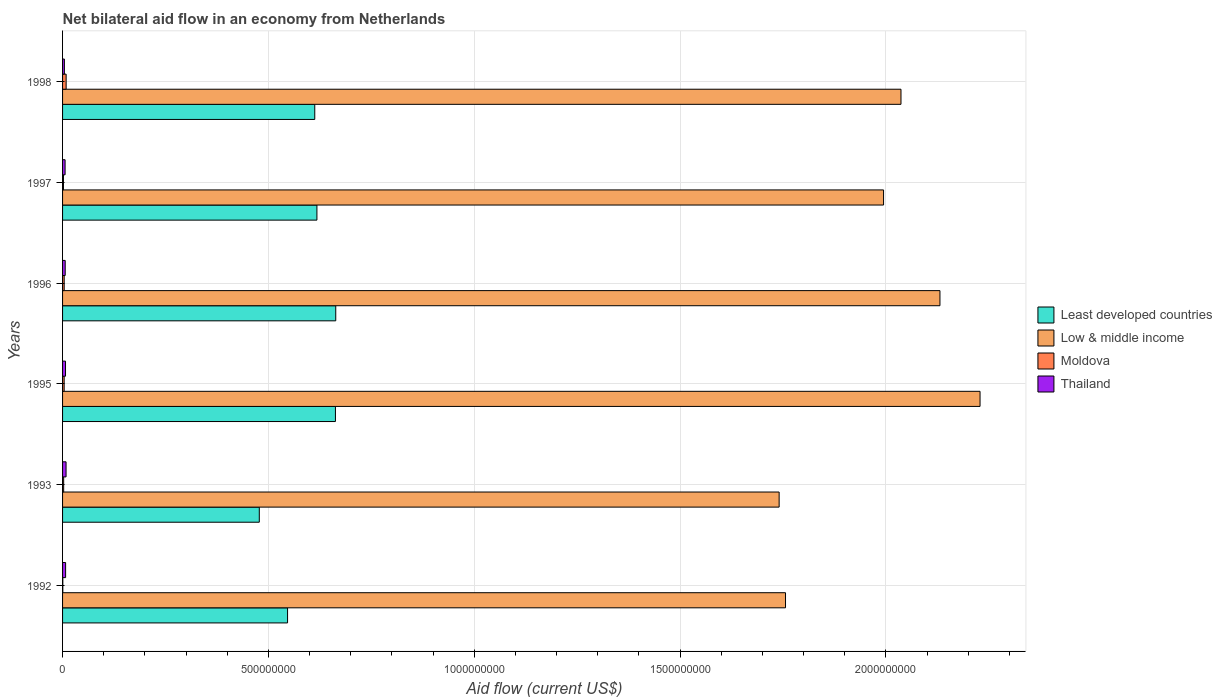Are the number of bars per tick equal to the number of legend labels?
Provide a short and direct response. Yes. What is the label of the 6th group of bars from the top?
Give a very brief answer. 1992. What is the net bilateral aid flow in Thailand in 1998?
Your response must be concise. 4.42e+06. Across all years, what is the maximum net bilateral aid flow in Moldova?
Your answer should be very brief. 8.70e+06. Across all years, what is the minimum net bilateral aid flow in Moldova?
Provide a succinct answer. 6.00e+05. In which year was the net bilateral aid flow in Least developed countries maximum?
Provide a succinct answer. 1996. In which year was the net bilateral aid flow in Least developed countries minimum?
Ensure brevity in your answer.  1993. What is the total net bilateral aid flow in Moldova in the graph?
Offer a terse response. 2.20e+07. What is the difference between the net bilateral aid flow in Low & middle income in 1993 and that in 1995?
Ensure brevity in your answer.  -4.88e+08. What is the difference between the net bilateral aid flow in Low & middle income in 1996 and the net bilateral aid flow in Least developed countries in 1995?
Keep it short and to the point. 1.47e+09. What is the average net bilateral aid flow in Moldova per year?
Provide a succinct answer. 3.67e+06. In the year 1997, what is the difference between the net bilateral aid flow in Least developed countries and net bilateral aid flow in Low & middle income?
Give a very brief answer. -1.38e+09. In how many years, is the net bilateral aid flow in Moldova greater than 600000000 US$?
Give a very brief answer. 0. What is the ratio of the net bilateral aid flow in Moldova in 1992 to that in 1996?
Give a very brief answer. 0.15. Is the net bilateral aid flow in Least developed countries in 1995 less than that in 1998?
Your response must be concise. No. What is the difference between the highest and the second highest net bilateral aid flow in Thailand?
Offer a very short reply. 1.12e+06. What is the difference between the highest and the lowest net bilateral aid flow in Least developed countries?
Make the answer very short. 1.86e+08. What does the 2nd bar from the top in 1996 represents?
Your answer should be very brief. Moldova. What does the 3rd bar from the bottom in 1997 represents?
Ensure brevity in your answer.  Moldova. How many bars are there?
Your answer should be very brief. 24. Are all the bars in the graph horizontal?
Keep it short and to the point. Yes. Are the values on the major ticks of X-axis written in scientific E-notation?
Provide a short and direct response. No. Does the graph contain any zero values?
Offer a very short reply. No. Does the graph contain grids?
Your response must be concise. Yes. Where does the legend appear in the graph?
Keep it short and to the point. Center right. How are the legend labels stacked?
Keep it short and to the point. Vertical. What is the title of the graph?
Give a very brief answer. Net bilateral aid flow in an economy from Netherlands. What is the label or title of the X-axis?
Make the answer very short. Aid flow (current US$). What is the Aid flow (current US$) of Least developed countries in 1992?
Ensure brevity in your answer.  5.47e+08. What is the Aid flow (current US$) of Low & middle income in 1992?
Ensure brevity in your answer.  1.76e+09. What is the Aid flow (current US$) of Thailand in 1992?
Provide a succinct answer. 7.39e+06. What is the Aid flow (current US$) of Least developed countries in 1993?
Your answer should be compact. 4.78e+08. What is the Aid flow (current US$) in Low & middle income in 1993?
Your answer should be very brief. 1.74e+09. What is the Aid flow (current US$) in Moldova in 1993?
Offer a terse response. 2.69e+06. What is the Aid flow (current US$) of Thailand in 1993?
Keep it short and to the point. 8.51e+06. What is the Aid flow (current US$) of Least developed countries in 1995?
Your answer should be compact. 6.63e+08. What is the Aid flow (current US$) in Low & middle income in 1995?
Your response must be concise. 2.23e+09. What is the Aid flow (current US$) of Moldova in 1995?
Offer a very short reply. 3.87e+06. What is the Aid flow (current US$) of Thailand in 1995?
Provide a succinct answer. 7.16e+06. What is the Aid flow (current US$) of Least developed countries in 1996?
Provide a short and direct response. 6.64e+08. What is the Aid flow (current US$) in Low & middle income in 1996?
Your response must be concise. 2.13e+09. What is the Aid flow (current US$) of Moldova in 1996?
Offer a terse response. 3.95e+06. What is the Aid flow (current US$) in Thailand in 1996?
Your answer should be very brief. 6.42e+06. What is the Aid flow (current US$) of Least developed countries in 1997?
Provide a short and direct response. 6.18e+08. What is the Aid flow (current US$) in Low & middle income in 1997?
Your answer should be very brief. 1.99e+09. What is the Aid flow (current US$) in Moldova in 1997?
Offer a terse response. 2.19e+06. What is the Aid flow (current US$) of Thailand in 1997?
Provide a short and direct response. 6.13e+06. What is the Aid flow (current US$) in Least developed countries in 1998?
Ensure brevity in your answer.  6.13e+08. What is the Aid flow (current US$) in Low & middle income in 1998?
Make the answer very short. 2.04e+09. What is the Aid flow (current US$) in Moldova in 1998?
Ensure brevity in your answer.  8.70e+06. What is the Aid flow (current US$) of Thailand in 1998?
Give a very brief answer. 4.42e+06. Across all years, what is the maximum Aid flow (current US$) of Least developed countries?
Keep it short and to the point. 6.64e+08. Across all years, what is the maximum Aid flow (current US$) in Low & middle income?
Give a very brief answer. 2.23e+09. Across all years, what is the maximum Aid flow (current US$) in Moldova?
Your answer should be very brief. 8.70e+06. Across all years, what is the maximum Aid flow (current US$) in Thailand?
Your answer should be compact. 8.51e+06. Across all years, what is the minimum Aid flow (current US$) in Least developed countries?
Provide a short and direct response. 4.78e+08. Across all years, what is the minimum Aid flow (current US$) of Low & middle income?
Provide a succinct answer. 1.74e+09. Across all years, what is the minimum Aid flow (current US$) in Moldova?
Provide a short and direct response. 6.00e+05. Across all years, what is the minimum Aid flow (current US$) of Thailand?
Give a very brief answer. 4.42e+06. What is the total Aid flow (current US$) of Least developed countries in the graph?
Keep it short and to the point. 3.58e+09. What is the total Aid flow (current US$) in Low & middle income in the graph?
Offer a terse response. 1.19e+1. What is the total Aid flow (current US$) in Moldova in the graph?
Keep it short and to the point. 2.20e+07. What is the total Aid flow (current US$) in Thailand in the graph?
Ensure brevity in your answer.  4.00e+07. What is the difference between the Aid flow (current US$) of Least developed countries in 1992 and that in 1993?
Make the answer very short. 6.87e+07. What is the difference between the Aid flow (current US$) of Low & middle income in 1992 and that in 1993?
Give a very brief answer. 1.55e+07. What is the difference between the Aid flow (current US$) in Moldova in 1992 and that in 1993?
Make the answer very short. -2.09e+06. What is the difference between the Aid flow (current US$) of Thailand in 1992 and that in 1993?
Offer a terse response. -1.12e+06. What is the difference between the Aid flow (current US$) in Least developed countries in 1992 and that in 1995?
Provide a short and direct response. -1.16e+08. What is the difference between the Aid flow (current US$) in Low & middle income in 1992 and that in 1995?
Give a very brief answer. -4.73e+08. What is the difference between the Aid flow (current US$) of Moldova in 1992 and that in 1995?
Offer a very short reply. -3.27e+06. What is the difference between the Aid flow (current US$) in Thailand in 1992 and that in 1995?
Ensure brevity in your answer.  2.30e+05. What is the difference between the Aid flow (current US$) of Least developed countries in 1992 and that in 1996?
Give a very brief answer. -1.17e+08. What is the difference between the Aid flow (current US$) of Low & middle income in 1992 and that in 1996?
Offer a terse response. -3.75e+08. What is the difference between the Aid flow (current US$) in Moldova in 1992 and that in 1996?
Give a very brief answer. -3.35e+06. What is the difference between the Aid flow (current US$) in Thailand in 1992 and that in 1996?
Offer a very short reply. 9.70e+05. What is the difference between the Aid flow (current US$) of Least developed countries in 1992 and that in 1997?
Provide a succinct answer. -7.13e+07. What is the difference between the Aid flow (current US$) in Low & middle income in 1992 and that in 1997?
Your answer should be very brief. -2.38e+08. What is the difference between the Aid flow (current US$) of Moldova in 1992 and that in 1997?
Provide a short and direct response. -1.59e+06. What is the difference between the Aid flow (current US$) in Thailand in 1992 and that in 1997?
Offer a terse response. 1.26e+06. What is the difference between the Aid flow (current US$) of Least developed countries in 1992 and that in 1998?
Provide a succinct answer. -6.61e+07. What is the difference between the Aid flow (current US$) of Low & middle income in 1992 and that in 1998?
Your answer should be very brief. -2.80e+08. What is the difference between the Aid flow (current US$) of Moldova in 1992 and that in 1998?
Your answer should be very brief. -8.10e+06. What is the difference between the Aid flow (current US$) of Thailand in 1992 and that in 1998?
Your answer should be compact. 2.97e+06. What is the difference between the Aid flow (current US$) in Least developed countries in 1993 and that in 1995?
Give a very brief answer. -1.85e+08. What is the difference between the Aid flow (current US$) in Low & middle income in 1993 and that in 1995?
Offer a terse response. -4.88e+08. What is the difference between the Aid flow (current US$) of Moldova in 1993 and that in 1995?
Your answer should be very brief. -1.18e+06. What is the difference between the Aid flow (current US$) in Thailand in 1993 and that in 1995?
Ensure brevity in your answer.  1.35e+06. What is the difference between the Aid flow (current US$) of Least developed countries in 1993 and that in 1996?
Your answer should be very brief. -1.86e+08. What is the difference between the Aid flow (current US$) of Low & middle income in 1993 and that in 1996?
Your answer should be compact. -3.91e+08. What is the difference between the Aid flow (current US$) of Moldova in 1993 and that in 1996?
Your response must be concise. -1.26e+06. What is the difference between the Aid flow (current US$) of Thailand in 1993 and that in 1996?
Make the answer very short. 2.09e+06. What is the difference between the Aid flow (current US$) of Least developed countries in 1993 and that in 1997?
Offer a very short reply. -1.40e+08. What is the difference between the Aid flow (current US$) of Low & middle income in 1993 and that in 1997?
Offer a terse response. -2.54e+08. What is the difference between the Aid flow (current US$) in Moldova in 1993 and that in 1997?
Your answer should be compact. 5.00e+05. What is the difference between the Aid flow (current US$) in Thailand in 1993 and that in 1997?
Your answer should be compact. 2.38e+06. What is the difference between the Aid flow (current US$) in Least developed countries in 1993 and that in 1998?
Offer a terse response. -1.35e+08. What is the difference between the Aid flow (current US$) of Low & middle income in 1993 and that in 1998?
Keep it short and to the point. -2.96e+08. What is the difference between the Aid flow (current US$) in Moldova in 1993 and that in 1998?
Offer a very short reply. -6.01e+06. What is the difference between the Aid flow (current US$) of Thailand in 1993 and that in 1998?
Offer a very short reply. 4.09e+06. What is the difference between the Aid flow (current US$) of Least developed countries in 1995 and that in 1996?
Your answer should be very brief. -7.40e+05. What is the difference between the Aid flow (current US$) in Low & middle income in 1995 and that in 1996?
Keep it short and to the point. 9.74e+07. What is the difference between the Aid flow (current US$) of Thailand in 1995 and that in 1996?
Ensure brevity in your answer.  7.40e+05. What is the difference between the Aid flow (current US$) in Least developed countries in 1995 and that in 1997?
Provide a succinct answer. 4.50e+07. What is the difference between the Aid flow (current US$) of Low & middle income in 1995 and that in 1997?
Ensure brevity in your answer.  2.34e+08. What is the difference between the Aid flow (current US$) of Moldova in 1995 and that in 1997?
Your response must be concise. 1.68e+06. What is the difference between the Aid flow (current US$) of Thailand in 1995 and that in 1997?
Your answer should be very brief. 1.03e+06. What is the difference between the Aid flow (current US$) in Least developed countries in 1995 and that in 1998?
Provide a succinct answer. 5.02e+07. What is the difference between the Aid flow (current US$) in Low & middle income in 1995 and that in 1998?
Ensure brevity in your answer.  1.92e+08. What is the difference between the Aid flow (current US$) of Moldova in 1995 and that in 1998?
Your answer should be compact. -4.83e+06. What is the difference between the Aid flow (current US$) of Thailand in 1995 and that in 1998?
Provide a succinct answer. 2.74e+06. What is the difference between the Aid flow (current US$) in Least developed countries in 1996 and that in 1997?
Make the answer very short. 4.57e+07. What is the difference between the Aid flow (current US$) in Low & middle income in 1996 and that in 1997?
Ensure brevity in your answer.  1.37e+08. What is the difference between the Aid flow (current US$) in Moldova in 1996 and that in 1997?
Offer a terse response. 1.76e+06. What is the difference between the Aid flow (current US$) of Thailand in 1996 and that in 1997?
Offer a very short reply. 2.90e+05. What is the difference between the Aid flow (current US$) in Least developed countries in 1996 and that in 1998?
Give a very brief answer. 5.10e+07. What is the difference between the Aid flow (current US$) of Low & middle income in 1996 and that in 1998?
Offer a very short reply. 9.47e+07. What is the difference between the Aid flow (current US$) in Moldova in 1996 and that in 1998?
Your response must be concise. -4.75e+06. What is the difference between the Aid flow (current US$) in Thailand in 1996 and that in 1998?
Make the answer very short. 2.00e+06. What is the difference between the Aid flow (current US$) of Least developed countries in 1997 and that in 1998?
Offer a very short reply. 5.23e+06. What is the difference between the Aid flow (current US$) of Low & middle income in 1997 and that in 1998?
Provide a succinct answer. -4.23e+07. What is the difference between the Aid flow (current US$) of Moldova in 1997 and that in 1998?
Keep it short and to the point. -6.51e+06. What is the difference between the Aid flow (current US$) in Thailand in 1997 and that in 1998?
Keep it short and to the point. 1.71e+06. What is the difference between the Aid flow (current US$) of Least developed countries in 1992 and the Aid flow (current US$) of Low & middle income in 1993?
Offer a terse response. -1.19e+09. What is the difference between the Aid flow (current US$) of Least developed countries in 1992 and the Aid flow (current US$) of Moldova in 1993?
Offer a very short reply. 5.44e+08. What is the difference between the Aid flow (current US$) in Least developed countries in 1992 and the Aid flow (current US$) in Thailand in 1993?
Ensure brevity in your answer.  5.38e+08. What is the difference between the Aid flow (current US$) of Low & middle income in 1992 and the Aid flow (current US$) of Moldova in 1993?
Give a very brief answer. 1.75e+09. What is the difference between the Aid flow (current US$) in Low & middle income in 1992 and the Aid flow (current US$) in Thailand in 1993?
Provide a succinct answer. 1.75e+09. What is the difference between the Aid flow (current US$) in Moldova in 1992 and the Aid flow (current US$) in Thailand in 1993?
Your response must be concise. -7.91e+06. What is the difference between the Aid flow (current US$) of Least developed countries in 1992 and the Aid flow (current US$) of Low & middle income in 1995?
Your answer should be compact. -1.68e+09. What is the difference between the Aid flow (current US$) in Least developed countries in 1992 and the Aid flow (current US$) in Moldova in 1995?
Your answer should be very brief. 5.43e+08. What is the difference between the Aid flow (current US$) of Least developed countries in 1992 and the Aid flow (current US$) of Thailand in 1995?
Give a very brief answer. 5.39e+08. What is the difference between the Aid flow (current US$) in Low & middle income in 1992 and the Aid flow (current US$) in Moldova in 1995?
Provide a succinct answer. 1.75e+09. What is the difference between the Aid flow (current US$) in Low & middle income in 1992 and the Aid flow (current US$) in Thailand in 1995?
Ensure brevity in your answer.  1.75e+09. What is the difference between the Aid flow (current US$) in Moldova in 1992 and the Aid flow (current US$) in Thailand in 1995?
Give a very brief answer. -6.56e+06. What is the difference between the Aid flow (current US$) in Least developed countries in 1992 and the Aid flow (current US$) in Low & middle income in 1996?
Your answer should be very brief. -1.58e+09. What is the difference between the Aid flow (current US$) of Least developed countries in 1992 and the Aid flow (current US$) of Moldova in 1996?
Your answer should be compact. 5.43e+08. What is the difference between the Aid flow (current US$) in Least developed countries in 1992 and the Aid flow (current US$) in Thailand in 1996?
Keep it short and to the point. 5.40e+08. What is the difference between the Aid flow (current US$) of Low & middle income in 1992 and the Aid flow (current US$) of Moldova in 1996?
Ensure brevity in your answer.  1.75e+09. What is the difference between the Aid flow (current US$) of Low & middle income in 1992 and the Aid flow (current US$) of Thailand in 1996?
Keep it short and to the point. 1.75e+09. What is the difference between the Aid flow (current US$) in Moldova in 1992 and the Aid flow (current US$) in Thailand in 1996?
Make the answer very short. -5.82e+06. What is the difference between the Aid flow (current US$) of Least developed countries in 1992 and the Aid flow (current US$) of Low & middle income in 1997?
Offer a very short reply. -1.45e+09. What is the difference between the Aid flow (current US$) in Least developed countries in 1992 and the Aid flow (current US$) in Moldova in 1997?
Your answer should be compact. 5.44e+08. What is the difference between the Aid flow (current US$) of Least developed countries in 1992 and the Aid flow (current US$) of Thailand in 1997?
Your answer should be very brief. 5.40e+08. What is the difference between the Aid flow (current US$) in Low & middle income in 1992 and the Aid flow (current US$) in Moldova in 1997?
Offer a terse response. 1.75e+09. What is the difference between the Aid flow (current US$) in Low & middle income in 1992 and the Aid flow (current US$) in Thailand in 1997?
Offer a very short reply. 1.75e+09. What is the difference between the Aid flow (current US$) in Moldova in 1992 and the Aid flow (current US$) in Thailand in 1997?
Ensure brevity in your answer.  -5.53e+06. What is the difference between the Aid flow (current US$) of Least developed countries in 1992 and the Aid flow (current US$) of Low & middle income in 1998?
Provide a short and direct response. -1.49e+09. What is the difference between the Aid flow (current US$) of Least developed countries in 1992 and the Aid flow (current US$) of Moldova in 1998?
Ensure brevity in your answer.  5.38e+08. What is the difference between the Aid flow (current US$) in Least developed countries in 1992 and the Aid flow (current US$) in Thailand in 1998?
Give a very brief answer. 5.42e+08. What is the difference between the Aid flow (current US$) in Low & middle income in 1992 and the Aid flow (current US$) in Moldova in 1998?
Offer a very short reply. 1.75e+09. What is the difference between the Aid flow (current US$) of Low & middle income in 1992 and the Aid flow (current US$) of Thailand in 1998?
Ensure brevity in your answer.  1.75e+09. What is the difference between the Aid flow (current US$) in Moldova in 1992 and the Aid flow (current US$) in Thailand in 1998?
Make the answer very short. -3.82e+06. What is the difference between the Aid flow (current US$) in Least developed countries in 1993 and the Aid flow (current US$) in Low & middle income in 1995?
Offer a very short reply. -1.75e+09. What is the difference between the Aid flow (current US$) of Least developed countries in 1993 and the Aid flow (current US$) of Moldova in 1995?
Your answer should be compact. 4.74e+08. What is the difference between the Aid flow (current US$) of Least developed countries in 1993 and the Aid flow (current US$) of Thailand in 1995?
Make the answer very short. 4.71e+08. What is the difference between the Aid flow (current US$) in Low & middle income in 1993 and the Aid flow (current US$) in Moldova in 1995?
Give a very brief answer. 1.74e+09. What is the difference between the Aid flow (current US$) in Low & middle income in 1993 and the Aid flow (current US$) in Thailand in 1995?
Provide a short and direct response. 1.73e+09. What is the difference between the Aid flow (current US$) of Moldova in 1993 and the Aid flow (current US$) of Thailand in 1995?
Offer a terse response. -4.47e+06. What is the difference between the Aid flow (current US$) in Least developed countries in 1993 and the Aid flow (current US$) in Low & middle income in 1996?
Make the answer very short. -1.65e+09. What is the difference between the Aid flow (current US$) of Least developed countries in 1993 and the Aid flow (current US$) of Moldova in 1996?
Offer a terse response. 4.74e+08. What is the difference between the Aid flow (current US$) in Least developed countries in 1993 and the Aid flow (current US$) in Thailand in 1996?
Make the answer very short. 4.71e+08. What is the difference between the Aid flow (current US$) of Low & middle income in 1993 and the Aid flow (current US$) of Moldova in 1996?
Keep it short and to the point. 1.74e+09. What is the difference between the Aid flow (current US$) in Low & middle income in 1993 and the Aid flow (current US$) in Thailand in 1996?
Give a very brief answer. 1.73e+09. What is the difference between the Aid flow (current US$) in Moldova in 1993 and the Aid flow (current US$) in Thailand in 1996?
Offer a terse response. -3.73e+06. What is the difference between the Aid flow (current US$) of Least developed countries in 1993 and the Aid flow (current US$) of Low & middle income in 1997?
Give a very brief answer. -1.52e+09. What is the difference between the Aid flow (current US$) in Least developed countries in 1993 and the Aid flow (current US$) in Moldova in 1997?
Your response must be concise. 4.76e+08. What is the difference between the Aid flow (current US$) of Least developed countries in 1993 and the Aid flow (current US$) of Thailand in 1997?
Your answer should be very brief. 4.72e+08. What is the difference between the Aid flow (current US$) in Low & middle income in 1993 and the Aid flow (current US$) in Moldova in 1997?
Offer a very short reply. 1.74e+09. What is the difference between the Aid flow (current US$) in Low & middle income in 1993 and the Aid flow (current US$) in Thailand in 1997?
Keep it short and to the point. 1.73e+09. What is the difference between the Aid flow (current US$) in Moldova in 1993 and the Aid flow (current US$) in Thailand in 1997?
Your answer should be compact. -3.44e+06. What is the difference between the Aid flow (current US$) in Least developed countries in 1993 and the Aid flow (current US$) in Low & middle income in 1998?
Offer a very short reply. -1.56e+09. What is the difference between the Aid flow (current US$) of Least developed countries in 1993 and the Aid flow (current US$) of Moldova in 1998?
Give a very brief answer. 4.69e+08. What is the difference between the Aid flow (current US$) of Least developed countries in 1993 and the Aid flow (current US$) of Thailand in 1998?
Keep it short and to the point. 4.73e+08. What is the difference between the Aid flow (current US$) of Low & middle income in 1993 and the Aid flow (current US$) of Moldova in 1998?
Your answer should be very brief. 1.73e+09. What is the difference between the Aid flow (current US$) in Low & middle income in 1993 and the Aid flow (current US$) in Thailand in 1998?
Your answer should be very brief. 1.74e+09. What is the difference between the Aid flow (current US$) of Moldova in 1993 and the Aid flow (current US$) of Thailand in 1998?
Offer a very short reply. -1.73e+06. What is the difference between the Aid flow (current US$) of Least developed countries in 1995 and the Aid flow (current US$) of Low & middle income in 1996?
Make the answer very short. -1.47e+09. What is the difference between the Aid flow (current US$) in Least developed countries in 1995 and the Aid flow (current US$) in Moldova in 1996?
Your response must be concise. 6.59e+08. What is the difference between the Aid flow (current US$) of Least developed countries in 1995 and the Aid flow (current US$) of Thailand in 1996?
Your answer should be very brief. 6.56e+08. What is the difference between the Aid flow (current US$) of Low & middle income in 1995 and the Aid flow (current US$) of Moldova in 1996?
Ensure brevity in your answer.  2.22e+09. What is the difference between the Aid flow (current US$) of Low & middle income in 1995 and the Aid flow (current US$) of Thailand in 1996?
Your answer should be very brief. 2.22e+09. What is the difference between the Aid flow (current US$) in Moldova in 1995 and the Aid flow (current US$) in Thailand in 1996?
Make the answer very short. -2.55e+06. What is the difference between the Aid flow (current US$) in Least developed countries in 1995 and the Aid flow (current US$) in Low & middle income in 1997?
Provide a succinct answer. -1.33e+09. What is the difference between the Aid flow (current US$) of Least developed countries in 1995 and the Aid flow (current US$) of Moldova in 1997?
Your response must be concise. 6.61e+08. What is the difference between the Aid flow (current US$) of Least developed countries in 1995 and the Aid flow (current US$) of Thailand in 1997?
Your response must be concise. 6.57e+08. What is the difference between the Aid flow (current US$) of Low & middle income in 1995 and the Aid flow (current US$) of Moldova in 1997?
Your response must be concise. 2.23e+09. What is the difference between the Aid flow (current US$) in Low & middle income in 1995 and the Aid flow (current US$) in Thailand in 1997?
Make the answer very short. 2.22e+09. What is the difference between the Aid flow (current US$) in Moldova in 1995 and the Aid flow (current US$) in Thailand in 1997?
Make the answer very short. -2.26e+06. What is the difference between the Aid flow (current US$) of Least developed countries in 1995 and the Aid flow (current US$) of Low & middle income in 1998?
Ensure brevity in your answer.  -1.37e+09. What is the difference between the Aid flow (current US$) in Least developed countries in 1995 and the Aid flow (current US$) in Moldova in 1998?
Your answer should be compact. 6.54e+08. What is the difference between the Aid flow (current US$) of Least developed countries in 1995 and the Aid flow (current US$) of Thailand in 1998?
Provide a short and direct response. 6.58e+08. What is the difference between the Aid flow (current US$) of Low & middle income in 1995 and the Aid flow (current US$) of Moldova in 1998?
Your answer should be very brief. 2.22e+09. What is the difference between the Aid flow (current US$) of Low & middle income in 1995 and the Aid flow (current US$) of Thailand in 1998?
Your answer should be very brief. 2.22e+09. What is the difference between the Aid flow (current US$) in Moldova in 1995 and the Aid flow (current US$) in Thailand in 1998?
Your answer should be very brief. -5.50e+05. What is the difference between the Aid flow (current US$) of Least developed countries in 1996 and the Aid flow (current US$) of Low & middle income in 1997?
Your answer should be very brief. -1.33e+09. What is the difference between the Aid flow (current US$) in Least developed countries in 1996 and the Aid flow (current US$) in Moldova in 1997?
Keep it short and to the point. 6.61e+08. What is the difference between the Aid flow (current US$) in Least developed countries in 1996 and the Aid flow (current US$) in Thailand in 1997?
Ensure brevity in your answer.  6.57e+08. What is the difference between the Aid flow (current US$) in Low & middle income in 1996 and the Aid flow (current US$) in Moldova in 1997?
Your response must be concise. 2.13e+09. What is the difference between the Aid flow (current US$) in Low & middle income in 1996 and the Aid flow (current US$) in Thailand in 1997?
Your response must be concise. 2.13e+09. What is the difference between the Aid flow (current US$) in Moldova in 1996 and the Aid flow (current US$) in Thailand in 1997?
Ensure brevity in your answer.  -2.18e+06. What is the difference between the Aid flow (current US$) in Least developed countries in 1996 and the Aid flow (current US$) in Low & middle income in 1998?
Ensure brevity in your answer.  -1.37e+09. What is the difference between the Aid flow (current US$) of Least developed countries in 1996 and the Aid flow (current US$) of Moldova in 1998?
Give a very brief answer. 6.55e+08. What is the difference between the Aid flow (current US$) of Least developed countries in 1996 and the Aid flow (current US$) of Thailand in 1998?
Offer a terse response. 6.59e+08. What is the difference between the Aid flow (current US$) of Low & middle income in 1996 and the Aid flow (current US$) of Moldova in 1998?
Provide a short and direct response. 2.12e+09. What is the difference between the Aid flow (current US$) of Low & middle income in 1996 and the Aid flow (current US$) of Thailand in 1998?
Your answer should be very brief. 2.13e+09. What is the difference between the Aid flow (current US$) in Moldova in 1996 and the Aid flow (current US$) in Thailand in 1998?
Your response must be concise. -4.70e+05. What is the difference between the Aid flow (current US$) in Least developed countries in 1997 and the Aid flow (current US$) in Low & middle income in 1998?
Ensure brevity in your answer.  -1.42e+09. What is the difference between the Aid flow (current US$) in Least developed countries in 1997 and the Aid flow (current US$) in Moldova in 1998?
Give a very brief answer. 6.09e+08. What is the difference between the Aid flow (current US$) of Least developed countries in 1997 and the Aid flow (current US$) of Thailand in 1998?
Your response must be concise. 6.13e+08. What is the difference between the Aid flow (current US$) in Low & middle income in 1997 and the Aid flow (current US$) in Moldova in 1998?
Give a very brief answer. 1.99e+09. What is the difference between the Aid flow (current US$) of Low & middle income in 1997 and the Aid flow (current US$) of Thailand in 1998?
Give a very brief answer. 1.99e+09. What is the difference between the Aid flow (current US$) of Moldova in 1997 and the Aid flow (current US$) of Thailand in 1998?
Offer a terse response. -2.23e+06. What is the average Aid flow (current US$) in Least developed countries per year?
Your answer should be very brief. 5.97e+08. What is the average Aid flow (current US$) in Low & middle income per year?
Give a very brief answer. 1.98e+09. What is the average Aid flow (current US$) of Moldova per year?
Keep it short and to the point. 3.67e+06. What is the average Aid flow (current US$) in Thailand per year?
Your answer should be compact. 6.67e+06. In the year 1992, what is the difference between the Aid flow (current US$) in Least developed countries and Aid flow (current US$) in Low & middle income?
Offer a terse response. -1.21e+09. In the year 1992, what is the difference between the Aid flow (current US$) in Least developed countries and Aid flow (current US$) in Moldova?
Make the answer very short. 5.46e+08. In the year 1992, what is the difference between the Aid flow (current US$) in Least developed countries and Aid flow (current US$) in Thailand?
Your answer should be compact. 5.39e+08. In the year 1992, what is the difference between the Aid flow (current US$) of Low & middle income and Aid flow (current US$) of Moldova?
Keep it short and to the point. 1.76e+09. In the year 1992, what is the difference between the Aid flow (current US$) of Low & middle income and Aid flow (current US$) of Thailand?
Offer a terse response. 1.75e+09. In the year 1992, what is the difference between the Aid flow (current US$) in Moldova and Aid flow (current US$) in Thailand?
Give a very brief answer. -6.79e+06. In the year 1993, what is the difference between the Aid flow (current US$) in Least developed countries and Aid flow (current US$) in Low & middle income?
Ensure brevity in your answer.  -1.26e+09. In the year 1993, what is the difference between the Aid flow (current US$) of Least developed countries and Aid flow (current US$) of Moldova?
Offer a very short reply. 4.75e+08. In the year 1993, what is the difference between the Aid flow (current US$) in Least developed countries and Aid flow (current US$) in Thailand?
Your answer should be very brief. 4.69e+08. In the year 1993, what is the difference between the Aid flow (current US$) of Low & middle income and Aid flow (current US$) of Moldova?
Offer a terse response. 1.74e+09. In the year 1993, what is the difference between the Aid flow (current US$) of Low & middle income and Aid flow (current US$) of Thailand?
Keep it short and to the point. 1.73e+09. In the year 1993, what is the difference between the Aid flow (current US$) in Moldova and Aid flow (current US$) in Thailand?
Your answer should be compact. -5.82e+06. In the year 1995, what is the difference between the Aid flow (current US$) of Least developed countries and Aid flow (current US$) of Low & middle income?
Provide a short and direct response. -1.57e+09. In the year 1995, what is the difference between the Aid flow (current US$) in Least developed countries and Aid flow (current US$) in Moldova?
Offer a very short reply. 6.59e+08. In the year 1995, what is the difference between the Aid flow (current US$) of Least developed countries and Aid flow (current US$) of Thailand?
Provide a succinct answer. 6.56e+08. In the year 1995, what is the difference between the Aid flow (current US$) of Low & middle income and Aid flow (current US$) of Moldova?
Your response must be concise. 2.22e+09. In the year 1995, what is the difference between the Aid flow (current US$) of Low & middle income and Aid flow (current US$) of Thailand?
Your response must be concise. 2.22e+09. In the year 1995, what is the difference between the Aid flow (current US$) in Moldova and Aid flow (current US$) in Thailand?
Provide a short and direct response. -3.29e+06. In the year 1996, what is the difference between the Aid flow (current US$) in Least developed countries and Aid flow (current US$) in Low & middle income?
Your response must be concise. -1.47e+09. In the year 1996, what is the difference between the Aid flow (current US$) of Least developed countries and Aid flow (current US$) of Moldova?
Give a very brief answer. 6.60e+08. In the year 1996, what is the difference between the Aid flow (current US$) in Least developed countries and Aid flow (current US$) in Thailand?
Keep it short and to the point. 6.57e+08. In the year 1996, what is the difference between the Aid flow (current US$) in Low & middle income and Aid flow (current US$) in Moldova?
Offer a terse response. 2.13e+09. In the year 1996, what is the difference between the Aid flow (current US$) of Low & middle income and Aid flow (current US$) of Thailand?
Provide a short and direct response. 2.12e+09. In the year 1996, what is the difference between the Aid flow (current US$) in Moldova and Aid flow (current US$) in Thailand?
Give a very brief answer. -2.47e+06. In the year 1997, what is the difference between the Aid flow (current US$) in Least developed countries and Aid flow (current US$) in Low & middle income?
Your answer should be very brief. -1.38e+09. In the year 1997, what is the difference between the Aid flow (current US$) of Least developed countries and Aid flow (current US$) of Moldova?
Give a very brief answer. 6.16e+08. In the year 1997, what is the difference between the Aid flow (current US$) in Least developed countries and Aid flow (current US$) in Thailand?
Make the answer very short. 6.12e+08. In the year 1997, what is the difference between the Aid flow (current US$) in Low & middle income and Aid flow (current US$) in Moldova?
Your response must be concise. 1.99e+09. In the year 1997, what is the difference between the Aid flow (current US$) of Low & middle income and Aid flow (current US$) of Thailand?
Your response must be concise. 1.99e+09. In the year 1997, what is the difference between the Aid flow (current US$) in Moldova and Aid flow (current US$) in Thailand?
Provide a succinct answer. -3.94e+06. In the year 1998, what is the difference between the Aid flow (current US$) in Least developed countries and Aid flow (current US$) in Low & middle income?
Give a very brief answer. -1.42e+09. In the year 1998, what is the difference between the Aid flow (current US$) in Least developed countries and Aid flow (current US$) in Moldova?
Offer a very short reply. 6.04e+08. In the year 1998, what is the difference between the Aid flow (current US$) in Least developed countries and Aid flow (current US$) in Thailand?
Ensure brevity in your answer.  6.08e+08. In the year 1998, what is the difference between the Aid flow (current US$) of Low & middle income and Aid flow (current US$) of Moldova?
Give a very brief answer. 2.03e+09. In the year 1998, what is the difference between the Aid flow (current US$) in Low & middle income and Aid flow (current US$) in Thailand?
Offer a very short reply. 2.03e+09. In the year 1998, what is the difference between the Aid flow (current US$) in Moldova and Aid flow (current US$) in Thailand?
Your answer should be very brief. 4.28e+06. What is the ratio of the Aid flow (current US$) in Least developed countries in 1992 to that in 1993?
Offer a terse response. 1.14. What is the ratio of the Aid flow (current US$) of Low & middle income in 1992 to that in 1993?
Your answer should be very brief. 1.01. What is the ratio of the Aid flow (current US$) in Moldova in 1992 to that in 1993?
Ensure brevity in your answer.  0.22. What is the ratio of the Aid flow (current US$) in Thailand in 1992 to that in 1993?
Offer a very short reply. 0.87. What is the ratio of the Aid flow (current US$) in Least developed countries in 1992 to that in 1995?
Give a very brief answer. 0.82. What is the ratio of the Aid flow (current US$) of Low & middle income in 1992 to that in 1995?
Provide a short and direct response. 0.79. What is the ratio of the Aid flow (current US$) in Moldova in 1992 to that in 1995?
Keep it short and to the point. 0.15. What is the ratio of the Aid flow (current US$) of Thailand in 1992 to that in 1995?
Offer a very short reply. 1.03. What is the ratio of the Aid flow (current US$) in Least developed countries in 1992 to that in 1996?
Offer a terse response. 0.82. What is the ratio of the Aid flow (current US$) of Low & middle income in 1992 to that in 1996?
Make the answer very short. 0.82. What is the ratio of the Aid flow (current US$) of Moldova in 1992 to that in 1996?
Offer a terse response. 0.15. What is the ratio of the Aid flow (current US$) in Thailand in 1992 to that in 1996?
Offer a terse response. 1.15. What is the ratio of the Aid flow (current US$) in Least developed countries in 1992 to that in 1997?
Offer a terse response. 0.88. What is the ratio of the Aid flow (current US$) of Low & middle income in 1992 to that in 1997?
Your response must be concise. 0.88. What is the ratio of the Aid flow (current US$) of Moldova in 1992 to that in 1997?
Give a very brief answer. 0.27. What is the ratio of the Aid flow (current US$) in Thailand in 1992 to that in 1997?
Offer a terse response. 1.21. What is the ratio of the Aid flow (current US$) in Least developed countries in 1992 to that in 1998?
Your response must be concise. 0.89. What is the ratio of the Aid flow (current US$) of Low & middle income in 1992 to that in 1998?
Give a very brief answer. 0.86. What is the ratio of the Aid flow (current US$) in Moldova in 1992 to that in 1998?
Give a very brief answer. 0.07. What is the ratio of the Aid flow (current US$) of Thailand in 1992 to that in 1998?
Offer a very short reply. 1.67. What is the ratio of the Aid flow (current US$) in Least developed countries in 1993 to that in 1995?
Keep it short and to the point. 0.72. What is the ratio of the Aid flow (current US$) in Low & middle income in 1993 to that in 1995?
Provide a succinct answer. 0.78. What is the ratio of the Aid flow (current US$) in Moldova in 1993 to that in 1995?
Offer a very short reply. 0.7. What is the ratio of the Aid flow (current US$) of Thailand in 1993 to that in 1995?
Provide a succinct answer. 1.19. What is the ratio of the Aid flow (current US$) of Least developed countries in 1993 to that in 1996?
Offer a terse response. 0.72. What is the ratio of the Aid flow (current US$) in Low & middle income in 1993 to that in 1996?
Make the answer very short. 0.82. What is the ratio of the Aid flow (current US$) in Moldova in 1993 to that in 1996?
Your response must be concise. 0.68. What is the ratio of the Aid flow (current US$) of Thailand in 1993 to that in 1996?
Offer a terse response. 1.33. What is the ratio of the Aid flow (current US$) in Least developed countries in 1993 to that in 1997?
Offer a terse response. 0.77. What is the ratio of the Aid flow (current US$) of Low & middle income in 1993 to that in 1997?
Your answer should be very brief. 0.87. What is the ratio of the Aid flow (current US$) in Moldova in 1993 to that in 1997?
Ensure brevity in your answer.  1.23. What is the ratio of the Aid flow (current US$) of Thailand in 1993 to that in 1997?
Provide a succinct answer. 1.39. What is the ratio of the Aid flow (current US$) in Least developed countries in 1993 to that in 1998?
Make the answer very short. 0.78. What is the ratio of the Aid flow (current US$) of Low & middle income in 1993 to that in 1998?
Ensure brevity in your answer.  0.85. What is the ratio of the Aid flow (current US$) of Moldova in 1993 to that in 1998?
Ensure brevity in your answer.  0.31. What is the ratio of the Aid flow (current US$) of Thailand in 1993 to that in 1998?
Provide a succinct answer. 1.93. What is the ratio of the Aid flow (current US$) in Low & middle income in 1995 to that in 1996?
Provide a short and direct response. 1.05. What is the ratio of the Aid flow (current US$) in Moldova in 1995 to that in 1996?
Provide a short and direct response. 0.98. What is the ratio of the Aid flow (current US$) in Thailand in 1995 to that in 1996?
Provide a short and direct response. 1.12. What is the ratio of the Aid flow (current US$) of Least developed countries in 1995 to that in 1997?
Keep it short and to the point. 1.07. What is the ratio of the Aid flow (current US$) of Low & middle income in 1995 to that in 1997?
Offer a terse response. 1.12. What is the ratio of the Aid flow (current US$) in Moldova in 1995 to that in 1997?
Ensure brevity in your answer.  1.77. What is the ratio of the Aid flow (current US$) in Thailand in 1995 to that in 1997?
Offer a terse response. 1.17. What is the ratio of the Aid flow (current US$) in Least developed countries in 1995 to that in 1998?
Your answer should be compact. 1.08. What is the ratio of the Aid flow (current US$) in Low & middle income in 1995 to that in 1998?
Keep it short and to the point. 1.09. What is the ratio of the Aid flow (current US$) of Moldova in 1995 to that in 1998?
Ensure brevity in your answer.  0.44. What is the ratio of the Aid flow (current US$) of Thailand in 1995 to that in 1998?
Your answer should be compact. 1.62. What is the ratio of the Aid flow (current US$) in Least developed countries in 1996 to that in 1997?
Give a very brief answer. 1.07. What is the ratio of the Aid flow (current US$) in Low & middle income in 1996 to that in 1997?
Provide a succinct answer. 1.07. What is the ratio of the Aid flow (current US$) in Moldova in 1996 to that in 1997?
Offer a terse response. 1.8. What is the ratio of the Aid flow (current US$) in Thailand in 1996 to that in 1997?
Your response must be concise. 1.05. What is the ratio of the Aid flow (current US$) in Least developed countries in 1996 to that in 1998?
Offer a terse response. 1.08. What is the ratio of the Aid flow (current US$) of Low & middle income in 1996 to that in 1998?
Provide a short and direct response. 1.05. What is the ratio of the Aid flow (current US$) in Moldova in 1996 to that in 1998?
Keep it short and to the point. 0.45. What is the ratio of the Aid flow (current US$) in Thailand in 1996 to that in 1998?
Provide a succinct answer. 1.45. What is the ratio of the Aid flow (current US$) of Least developed countries in 1997 to that in 1998?
Ensure brevity in your answer.  1.01. What is the ratio of the Aid flow (current US$) of Low & middle income in 1997 to that in 1998?
Ensure brevity in your answer.  0.98. What is the ratio of the Aid flow (current US$) in Moldova in 1997 to that in 1998?
Provide a short and direct response. 0.25. What is the ratio of the Aid flow (current US$) in Thailand in 1997 to that in 1998?
Provide a short and direct response. 1.39. What is the difference between the highest and the second highest Aid flow (current US$) of Least developed countries?
Offer a very short reply. 7.40e+05. What is the difference between the highest and the second highest Aid flow (current US$) in Low & middle income?
Your answer should be very brief. 9.74e+07. What is the difference between the highest and the second highest Aid flow (current US$) of Moldova?
Make the answer very short. 4.75e+06. What is the difference between the highest and the second highest Aid flow (current US$) of Thailand?
Your answer should be compact. 1.12e+06. What is the difference between the highest and the lowest Aid flow (current US$) in Least developed countries?
Make the answer very short. 1.86e+08. What is the difference between the highest and the lowest Aid flow (current US$) in Low & middle income?
Provide a succinct answer. 4.88e+08. What is the difference between the highest and the lowest Aid flow (current US$) in Moldova?
Your answer should be very brief. 8.10e+06. What is the difference between the highest and the lowest Aid flow (current US$) of Thailand?
Provide a succinct answer. 4.09e+06. 